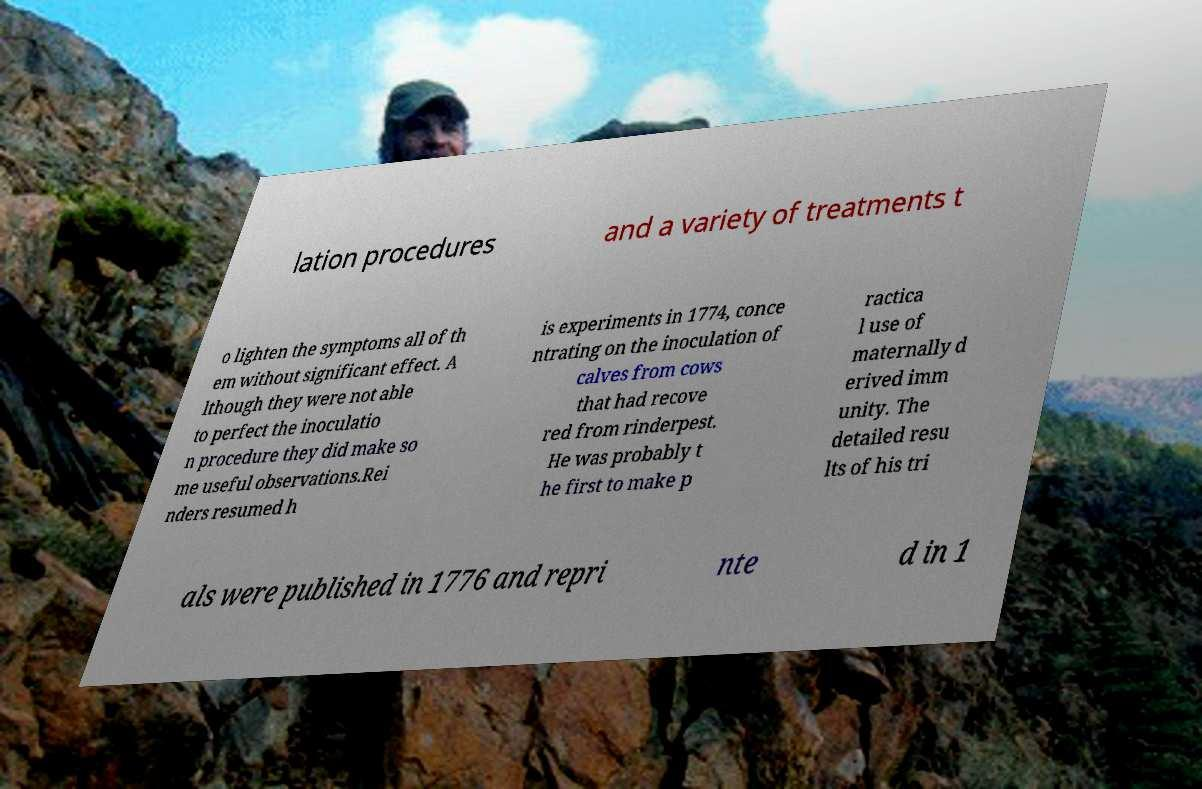What messages or text are displayed in this image? I need them in a readable, typed format. lation procedures and a variety of treatments t o lighten the symptoms all of th em without significant effect. A lthough they were not able to perfect the inoculatio n procedure they did make so me useful observations.Rei nders resumed h is experiments in 1774, conce ntrating on the inoculation of calves from cows that had recove red from rinderpest. He was probably t he first to make p ractica l use of maternally d erived imm unity. The detailed resu lts of his tri als were published in 1776 and repri nte d in 1 